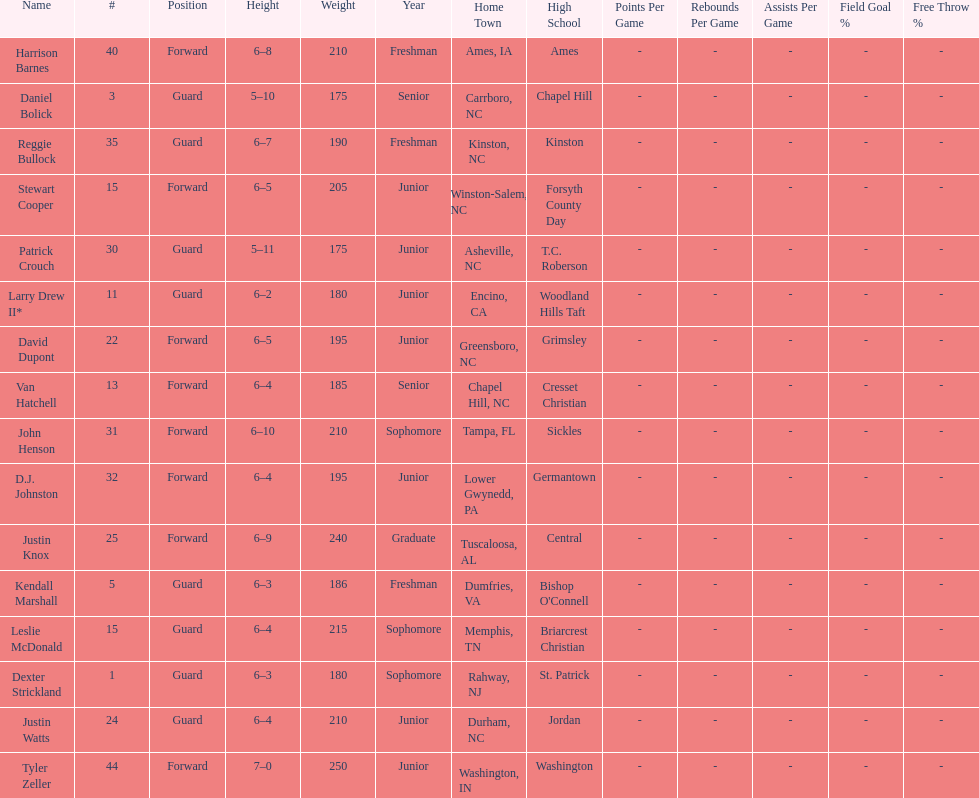How many players are not a junior? 9. 